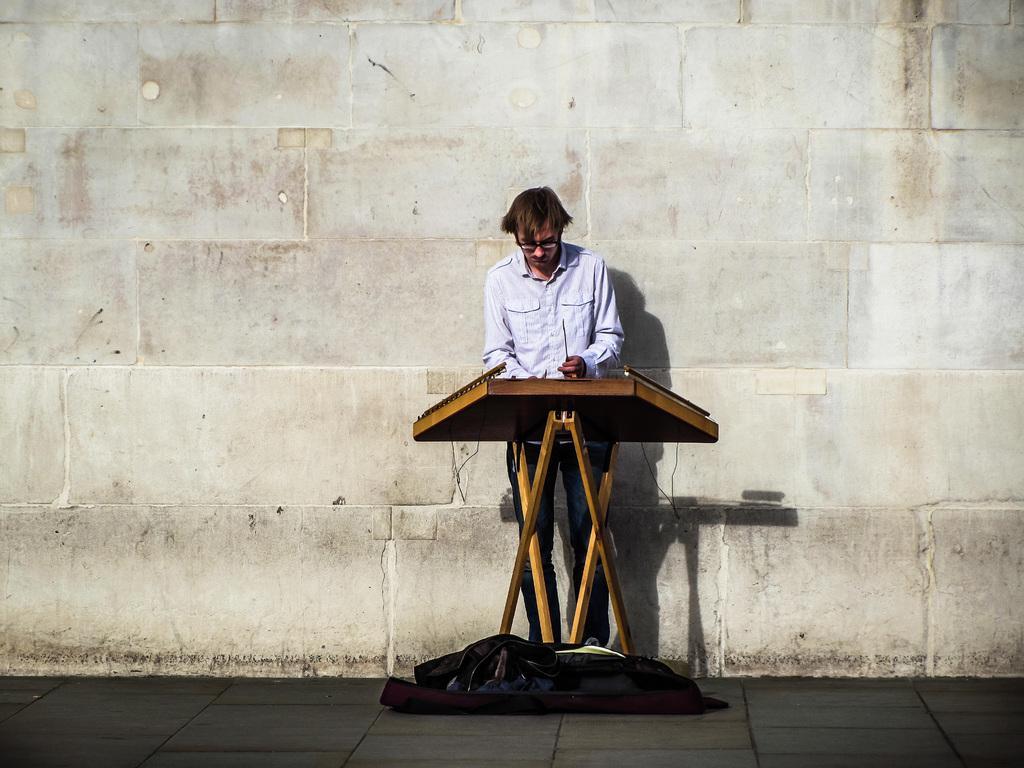How would you summarize this image in a sentence or two? In this image I see a man who is wearing shirt and jeans and I see that he is holding a thing in his hands and I see the wooden thing over here and I see the black color thing over here and I see the path. In the background I see the wall white, brown and black color wall. 